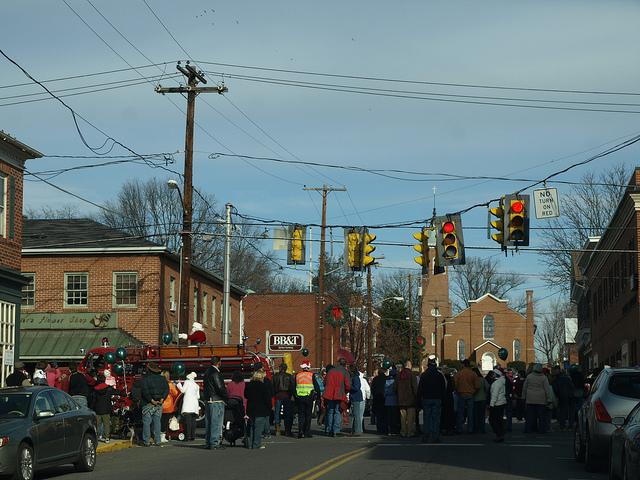Why are people in the middle of the street? Please explain your reasoning. parade passing. The people are lining the streets to watch the celebratory procession that is taking place there. santa can be seen riding on the top of the truck in the procession. 